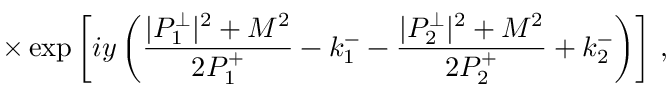Convert formula to latex. <formula><loc_0><loc_0><loc_500><loc_500>\times \exp \left [ i y \left ( \frac { | P _ { 1 } ^ { \perp } | ^ { 2 } + M ^ { 2 } } { 2 P _ { 1 } ^ { + } } - k _ { 1 } ^ { - } - \frac { | P _ { 2 } ^ { \perp } | ^ { 2 } + M ^ { 2 } } { 2 P _ { 2 } ^ { + } } + k _ { 2 } ^ { - } \right ) \right ] \, ,</formula> 